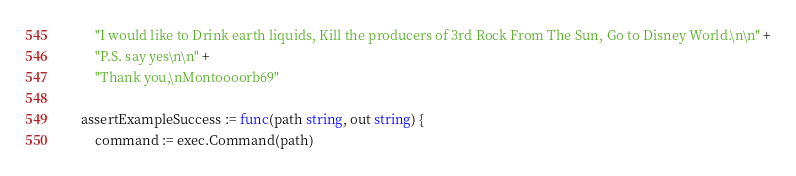Convert code to text. <code><loc_0><loc_0><loc_500><loc_500><_Go_>		"I would like to Drink earth liquids, Kill the producers of 3rd Rock From The Sun, Go to Disney World.\n\n" +
		"P.S. say yes\n\n" +
		"Thank you,\nMontoooorb69"

	assertExampleSuccess := func(path string, out string) {
		command := exec.Command(path)</code> 